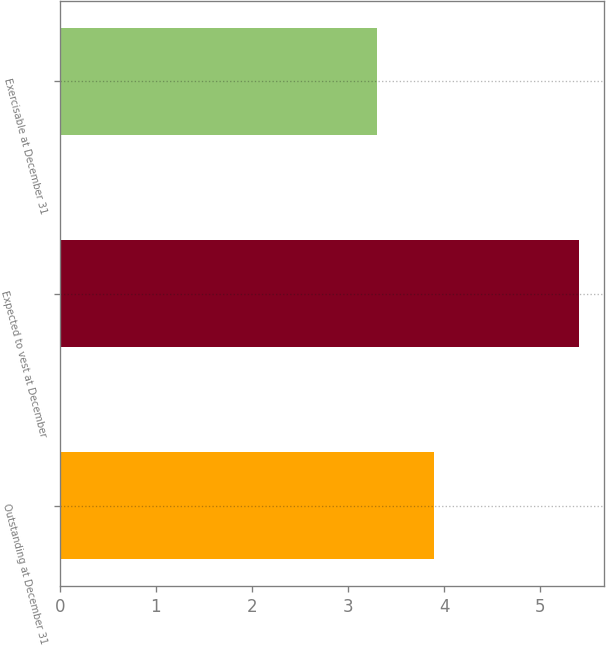Convert chart. <chart><loc_0><loc_0><loc_500><loc_500><bar_chart><fcel>Outstanding at December 31<fcel>Expected to vest at December<fcel>Exercisable at December 31<nl><fcel>3.9<fcel>5.4<fcel>3.3<nl></chart> 